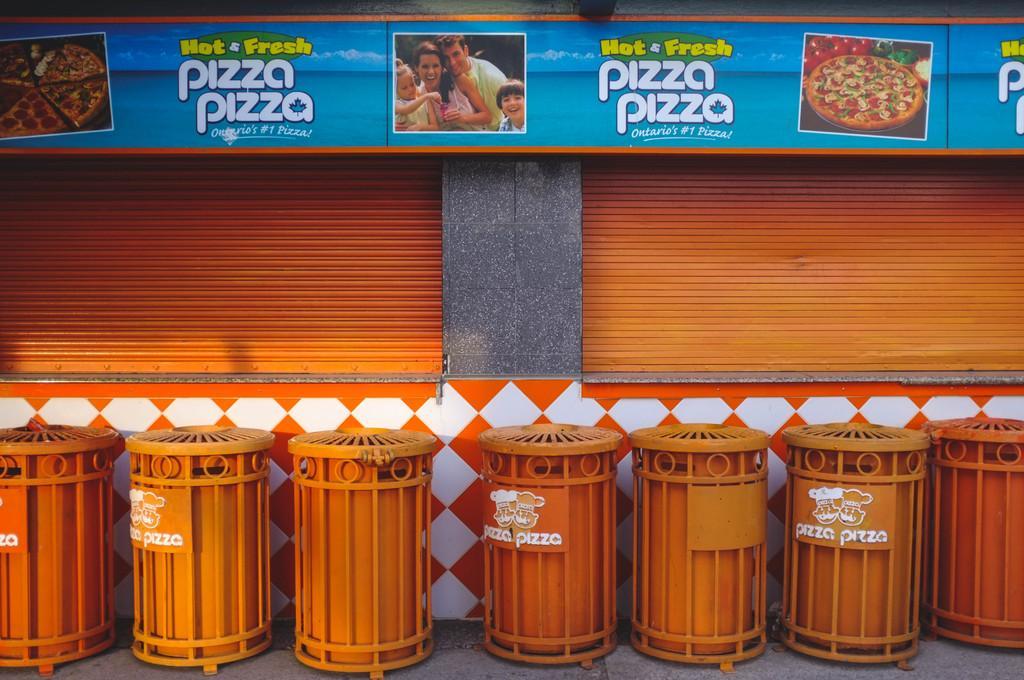Could you give a brief overview of what you see in this image? In this image I can see there are drums visible in front of the building , on the building wall I can see a hoarding board , on the hoarding board I can see person image and text and pizza image and I can see a orange color shatter in the middle. 